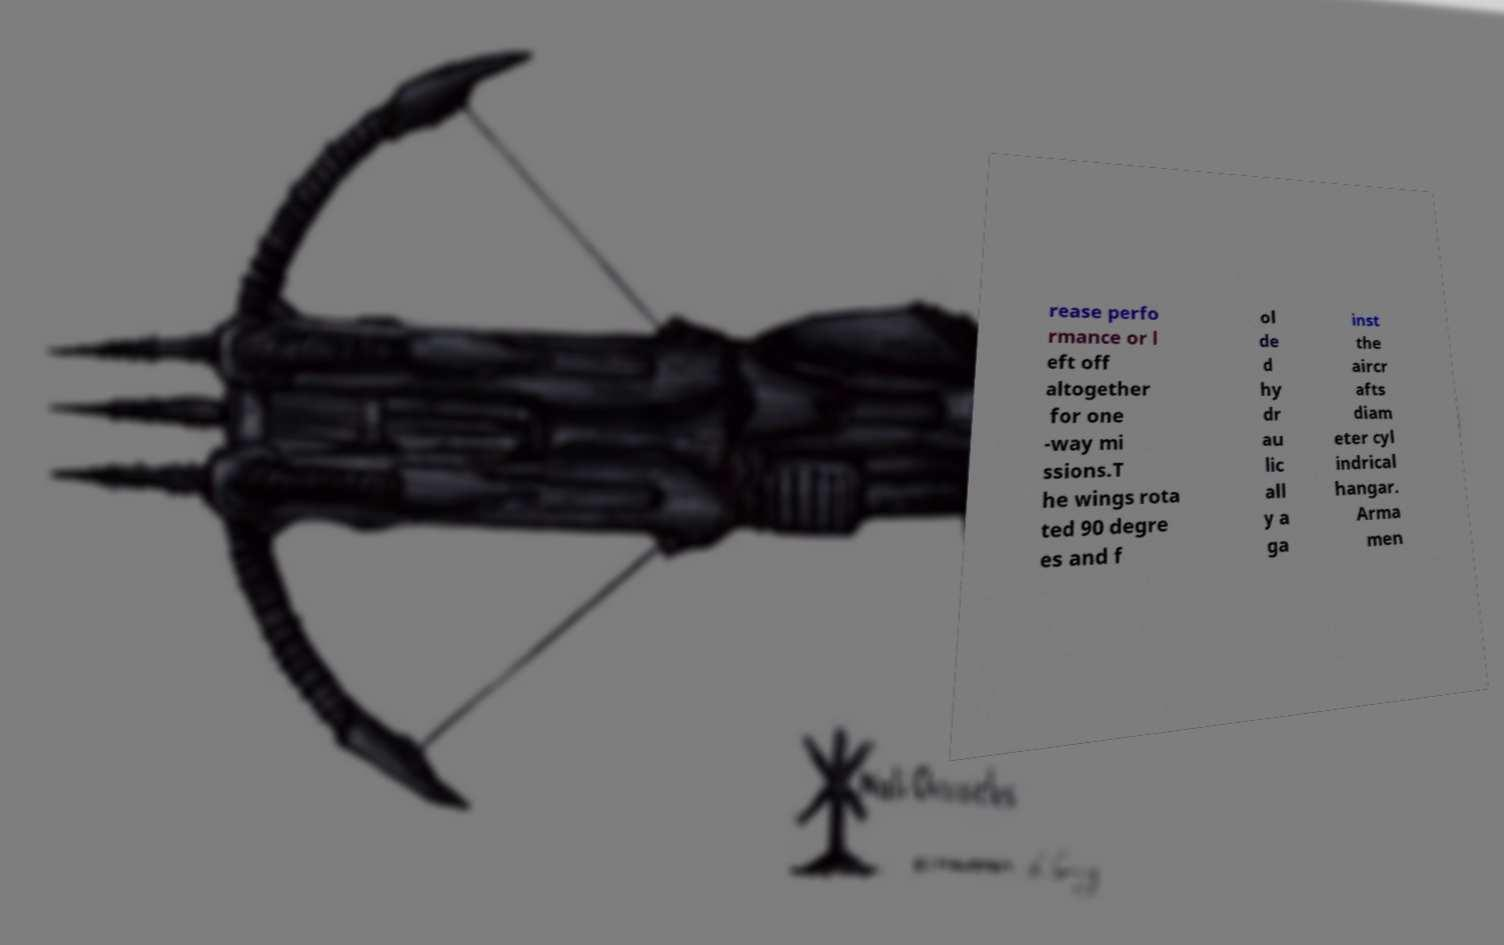Can you read and provide the text displayed in the image?This photo seems to have some interesting text. Can you extract and type it out for me? rease perfo rmance or l eft off altogether for one -way mi ssions.T he wings rota ted 90 degre es and f ol de d hy dr au lic all y a ga inst the aircr afts diam eter cyl indrical hangar. Arma men 